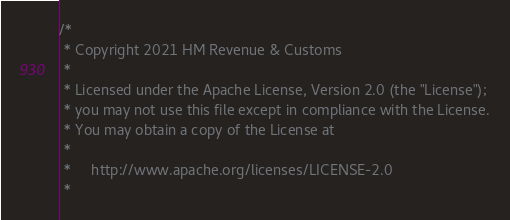<code> <loc_0><loc_0><loc_500><loc_500><_Scala_>/*
 * Copyright 2021 HM Revenue & Customs
 *
 * Licensed under the Apache License, Version 2.0 (the "License");
 * you may not use this file except in compliance with the License.
 * You may obtain a copy of the License at
 *
 *     http://www.apache.org/licenses/LICENSE-2.0
 *</code> 